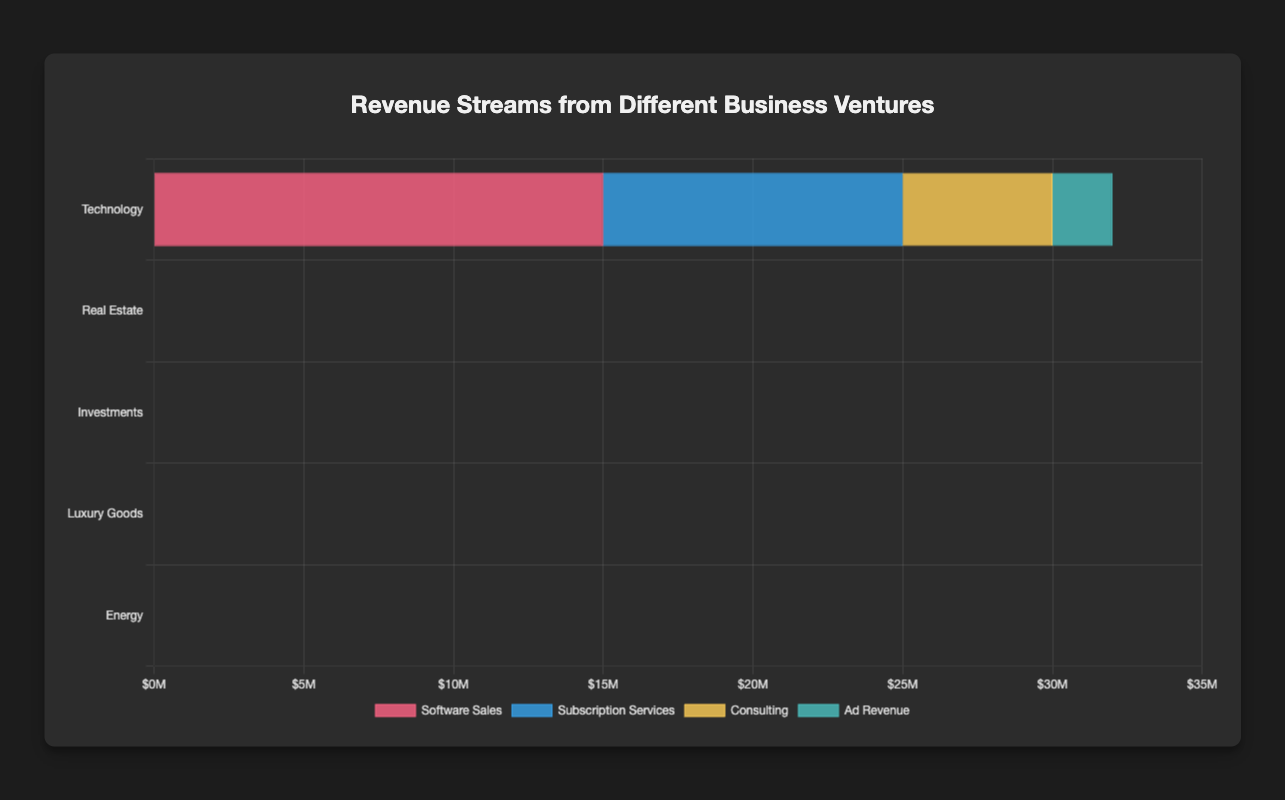What is the highest revenue stream in the Energy venture? The highest revenue stream in the Energy venture is identified by comparing the revenues listed under Energy: Oil and Gas ($30M), Green Energy ($12M), Energy Trading ($8M), and Utility Services ($11M). Oil and Gas has the highest revenue.
Answer: Oil and Gas Which venture has the highest total revenue from all streams combined? Sum up the revenues for each venture: Technology ($32M), Real Estate ($38M), Investments ($48M), Luxury Goods ($27M), and Energy ($61M). The Energy venture has the highest total revenue.
Answer: Energy What is the total revenue from Subscription Services across all business ventures? Only the Technology venture has Subscription Services with a revenue of $10M. Thus, the total is $10M.
Answer: $10M Which venture has the least revenue from its lowest revenue stream? Identify the lowest revenue stream for each venture: Technology (Ad Revenue $2M), Real Estate (Vacation Rentals $3M), Investments (Bonds $5M), Luxury Goods (Jewelry $6M), Energy (Energy Trading $8M). Technology's Ad Revenue has the least revenue overall.
Answer: Technology How does the total revenue from Consulting in the Technology venture compare to Bonds in the Investments venture? Consulting in Technology has a revenue of $5M, and Bonds in Investments also has a revenue of $5M. Both are equal.
Answer: Equal What is the combined revenue of the highest and lowest revenue streams in the Investments venture? The highest revenue stream in Investments is Stock Market ($25M), and the lowest is Bonds ($5M). Summing these gives $25M + $5M = $30M.
Answer: $30M Which revenue stream has the highest contribution in Luxury Goods? The highest revenue in Luxury Goods comes from High-end Fashion, which is $9M.
Answer: High-end Fashion What is the average revenue per stream in the Real Estate venture? Sum the revenues in Real Estate: Residential Rentals ($8M), Commercial Leases ($12M), Property Sales ($15M), Vacation Rentals ($3M). The total is $38M, divided by 4 streams, the average is $38M/4 = $9.5M.
Answer: $9.5M Compare the total revenue from Software Sales and Stock Market. Which one is higher? Software Sales (Technology) is $15M and Stock Market (Investments) is $25M. Stock Market is higher.
Answer: Stock Market What is the difference in total revenue between the Technology and Luxury Goods ventures? Sum the revenues: Technology ($32M), Luxury Goods ($27M). The difference is $32M - $27M = $5M.
Answer: $5M 